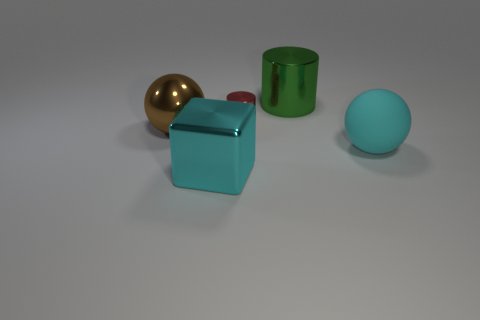Does the shiny object that is in front of the big matte sphere have the same shape as the green metallic object?
Offer a terse response. No. The cyan thing that is on the right side of the large green thing has what shape?
Make the answer very short. Sphere. What is the size of the object that is the same color as the block?
Ensure brevity in your answer.  Large. What is the material of the brown thing?
Your answer should be very brief. Metal. There is a rubber ball that is the same size as the cyan metal cube; what is its color?
Provide a succinct answer. Cyan. The metal thing that is the same color as the big matte sphere is what shape?
Give a very brief answer. Cube. Is the shape of the small red shiny object the same as the big cyan metal object?
Make the answer very short. No. What material is the big object that is both in front of the tiny red cylinder and right of the cyan cube?
Provide a succinct answer. Rubber. The green metal cylinder is what size?
Your answer should be very brief. Large. There is a large shiny object that is the same shape as the big cyan matte thing; what color is it?
Make the answer very short. Brown. 